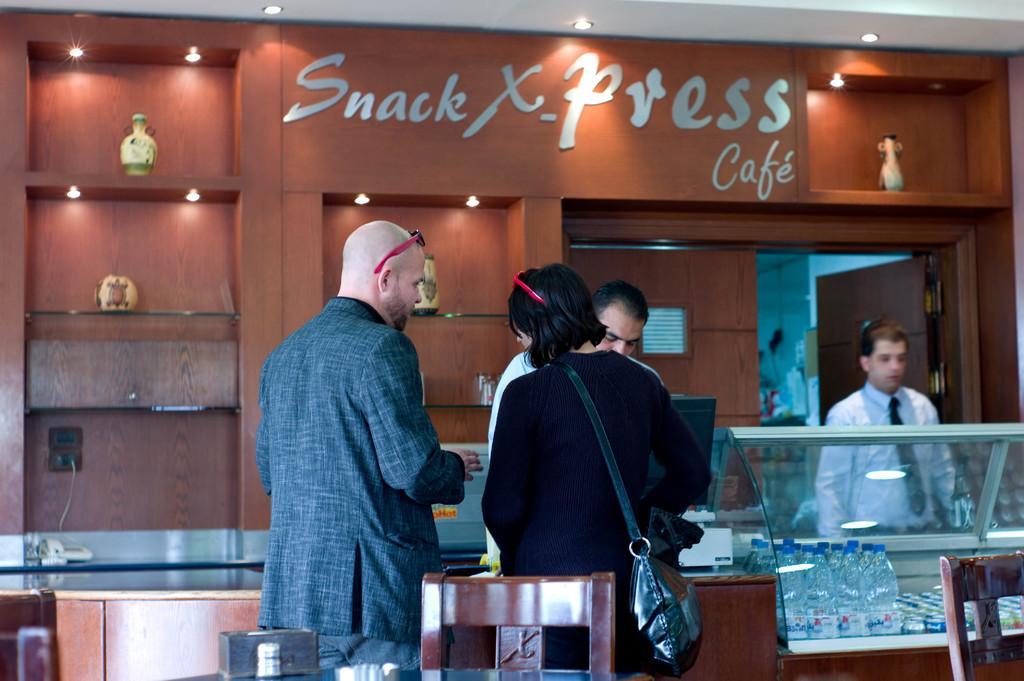Please provide a concise description of this image. In the picture we can see inside the restaurant with a man and woman standing near the desk and man is with bald head and woman is with hand bag and behind the desk we can see two men are standing they are in shirts and ties and in front of them we can see monitor and behind them we can see a wall which is brown in color and written on it as snack express cafe. 